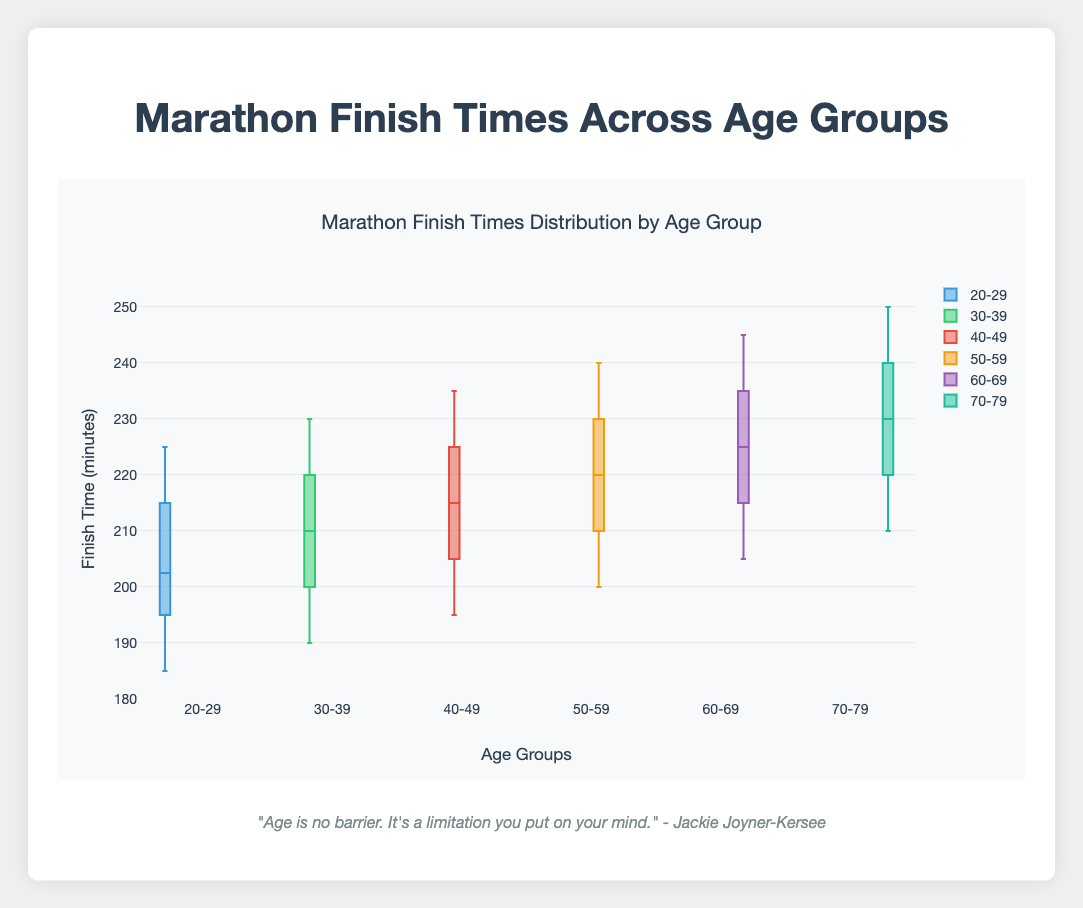Which age group has the lowest median finish time? The box plot shows that the 20-29 age group has their median line lower than any other groups, indicating the lowest median finish time.
Answer: 20-29 Which age group has the highest variability in finish times? Variability in a box plot is represented by the range between the minimum and maximum whiskers. The 70-79 age group has the largest spread from the bottom to the top of the whiskers.
Answer: 70-79 What is the upper quartile finish time for the 50-59 age group? The upper quartile represents the value at the top of the box in a box plot. For the 50-59 age group, this value is estimated to be around 230 minutes.
Answer: 230 minutes What is the interquartile range (IQR) for the 30-39 age group? The IQR is the range between the lower quartile (Q1) and upper quartile (Q3). For 30-39, Q1 is around 198 and Q3 is around 220, thus IQR = 220 - 198.
Answer: 22 minutes Which two age groups have the most similar finish time distributions? The most similar box plots will have similar medians, IQRs, and ranges. The 30-39 and 40-49 age groups show very comparable distributions in their finish times.
Answer: 30-39 and 40-49 Which age group has the greatest upper whisker value? The upper whisker extends to the maximum non-outlier value. For the 70-79 age group, the upper whisker reaches around 250 minutes, higher than the other groups.
Answer: 70-79 How does the median finish time change from age 20-29 to 60-69? To find this, compare the median line of the 20-29 group to that of the 60-69 group. There's a steady increase, with medians rising from around 200 to 225 minutes.
Answer: Increase from 200 to 225 minutes What is the range of finish times for the 60-69 age group? The range in finish times is the difference between the maximum and minimum whisker values. For the 60-69 age group, it is approximately from 205 to 245 minutes.
Answer: 40 minutes Which group has the smallest lower quartile finish time? The lower quartile represents the bottom of the box. For the 20-29 age group, this value is the smallest among all groups, estimated to be around 190 minutes.
Answer: 20-29 